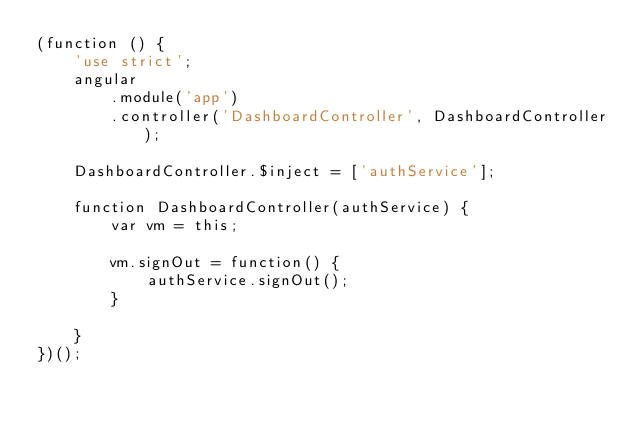Convert code to text. <code><loc_0><loc_0><loc_500><loc_500><_JavaScript_>(function () {
	'use strict';
	angular
		.module('app')
		.controller('DashboardController', DashboardController);

	DashboardController.$inject = ['authService'];

	function DashboardController(authService) {
		var vm = this;

        vm.signOut = function() {
            authService.signOut();
        }

	}
})();
</code> 